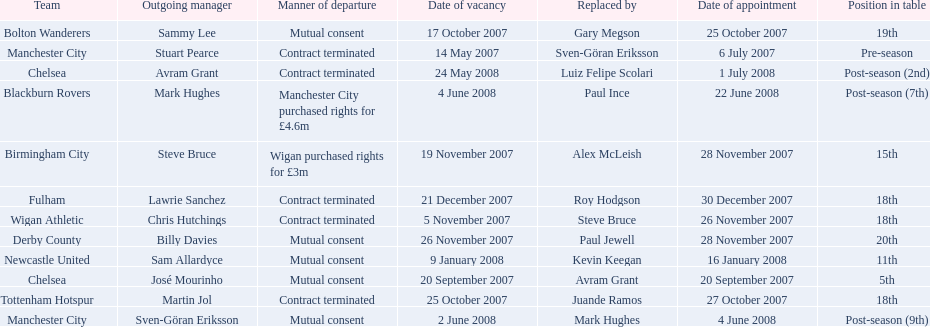How many outgoing managers were appointed in november 2007? 3. 